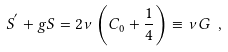Convert formula to latex. <formula><loc_0><loc_0><loc_500><loc_500>\label l { e q \colon S e q u a t i o n a g a i n } S ^ { ^ { \prime } } + g S = 2 \nu \left ( C _ { 0 } + \frac { 1 } { 4 } \right ) \equiv \nu G \ ,</formula> 